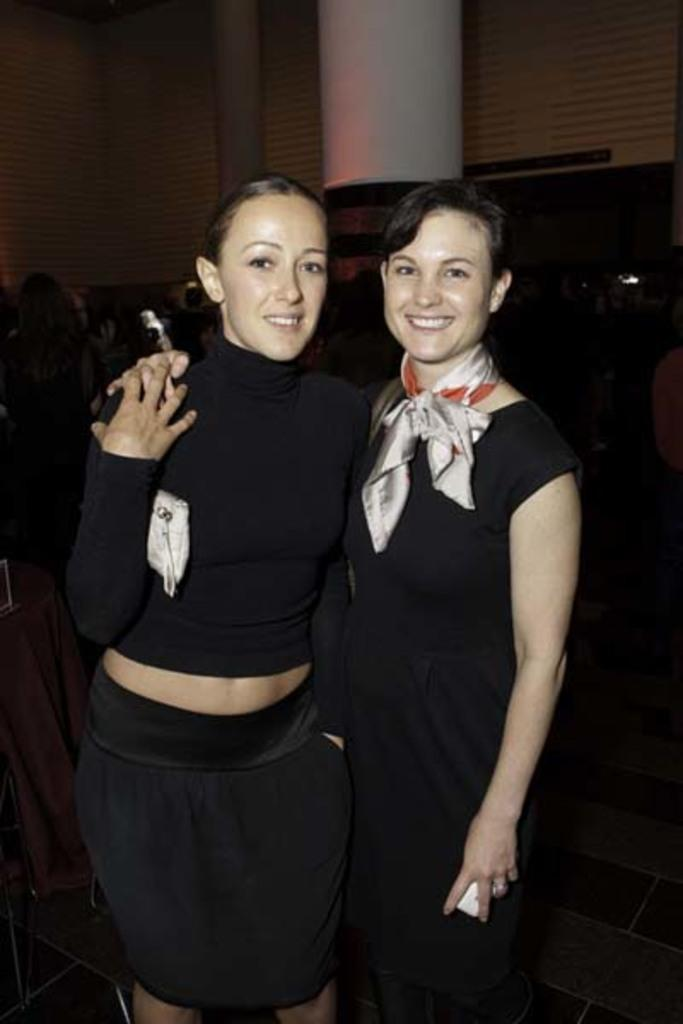How many women are in the image? There are two women in the image. What expression do the women have? The women are smiling. What color are the clothes the women are wearing? The women are wearing dark color clothes. What can be seen in the background of the image? There is a pillar and other objects visible in the background of the image. Where is the faucet located in the image? There is no faucet present in the image. What type of club is the women holding in the image? The women are not holding any clubs in the image. 